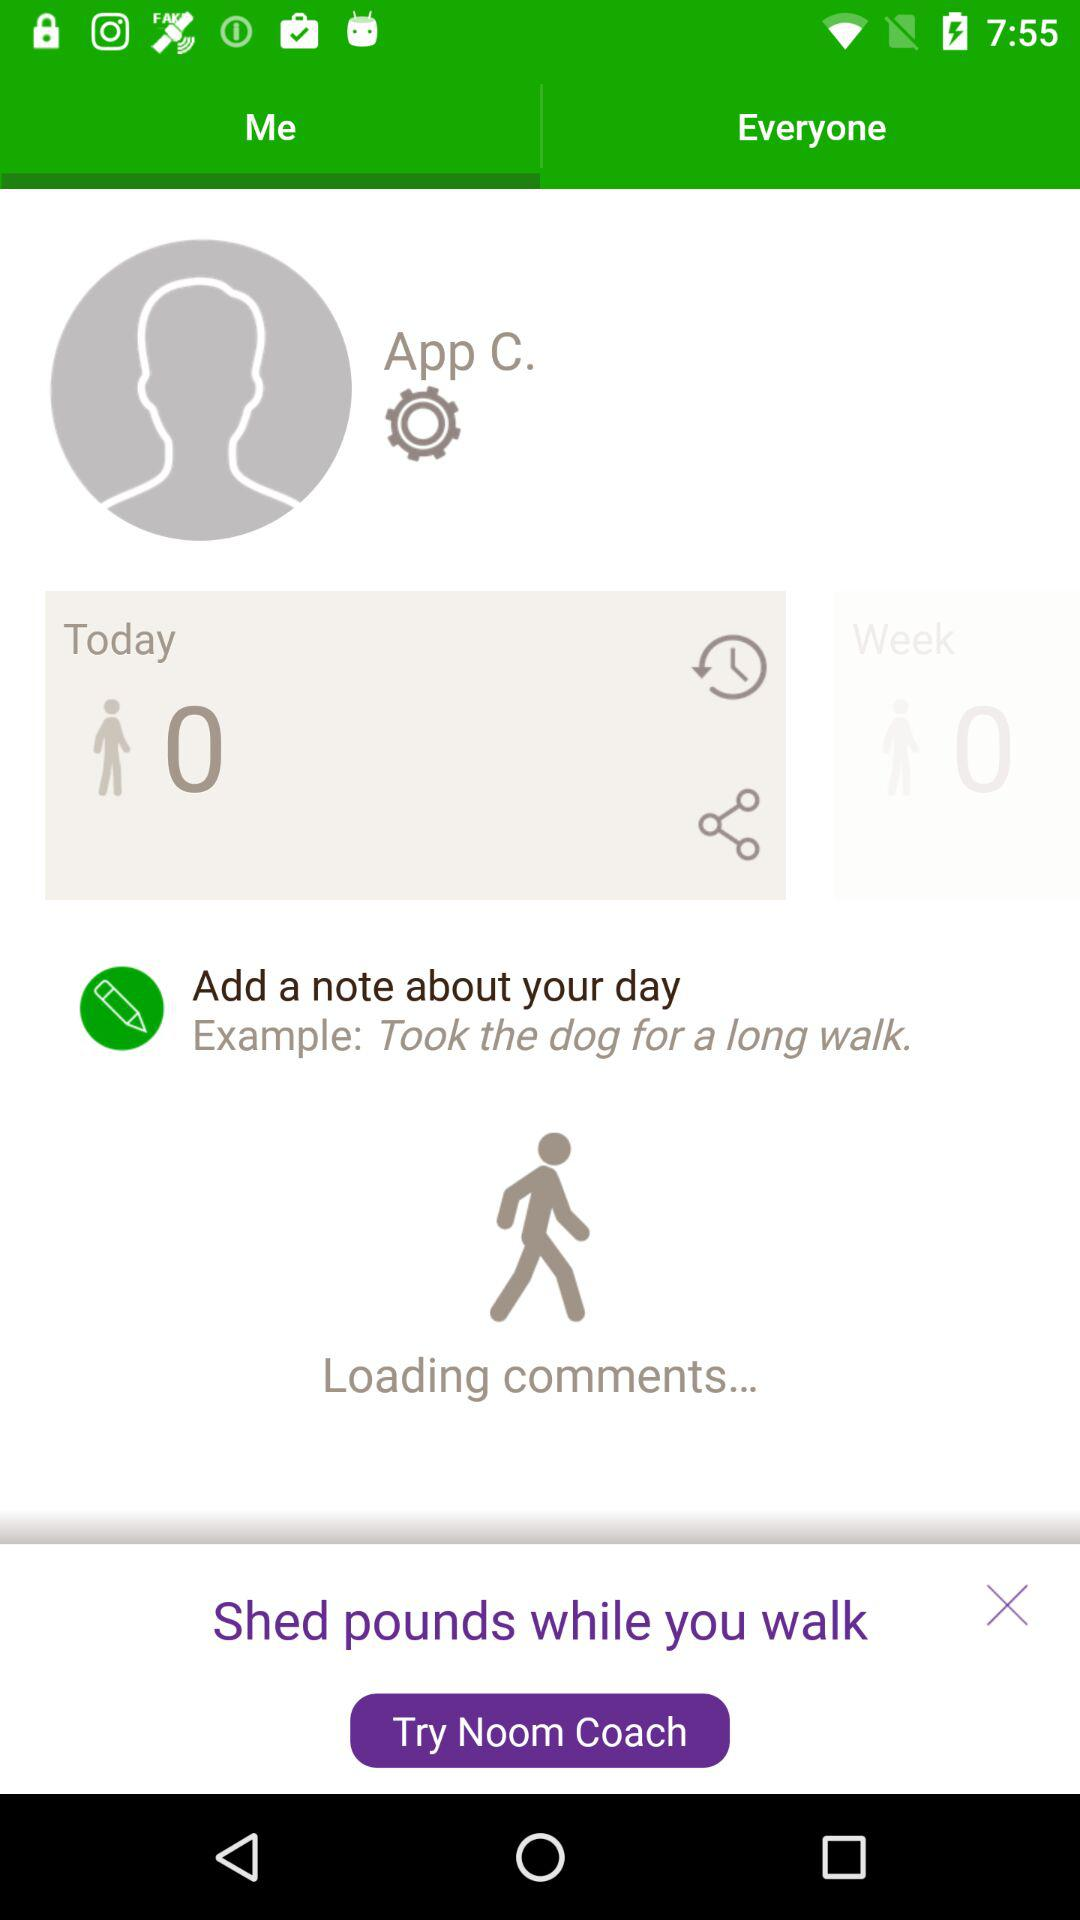How many steps has the user taken today?
Answer the question using a single word or phrase. 0 